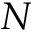<formula> <loc_0><loc_0><loc_500><loc_500>N</formula> 